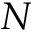<formula> <loc_0><loc_0><loc_500><loc_500>N</formula> 